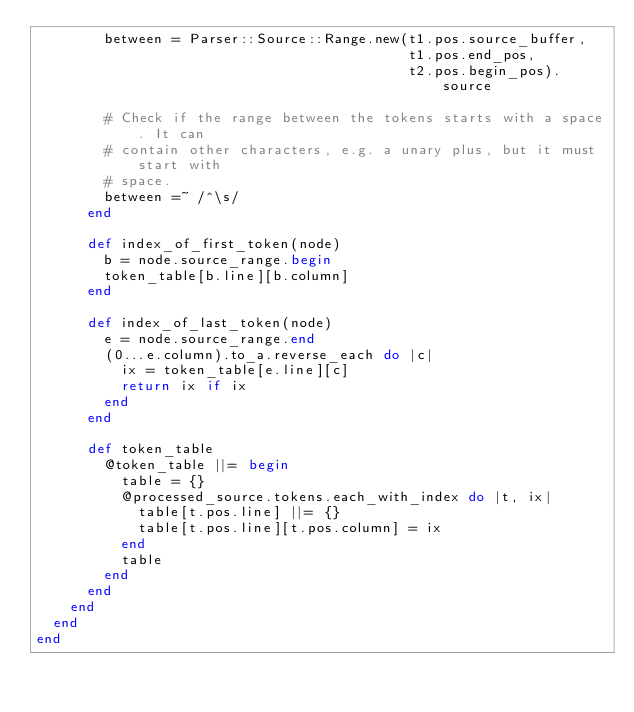<code> <loc_0><loc_0><loc_500><loc_500><_Ruby_>        between = Parser::Source::Range.new(t1.pos.source_buffer,
                                            t1.pos.end_pos,
                                            t2.pos.begin_pos).source

        # Check if the range between the tokens starts with a space. It can
        # contain other characters, e.g. a unary plus, but it must start with
        # space.
        between =~ /^\s/
      end

      def index_of_first_token(node)
        b = node.source_range.begin
        token_table[b.line][b.column]
      end

      def index_of_last_token(node)
        e = node.source_range.end
        (0...e.column).to_a.reverse_each do |c|
          ix = token_table[e.line][c]
          return ix if ix
        end
      end

      def token_table
        @token_table ||= begin
          table = {}
          @processed_source.tokens.each_with_index do |t, ix|
            table[t.pos.line] ||= {}
            table[t.pos.line][t.pos.column] = ix
          end
          table
        end
      end
    end
  end
end
</code> 